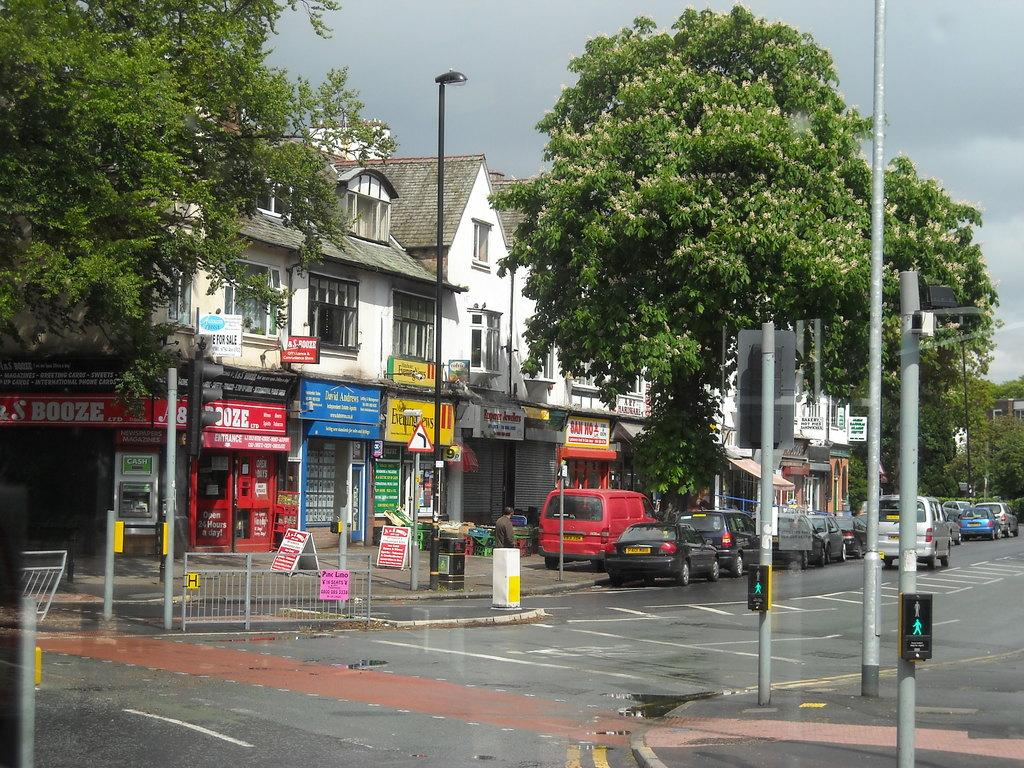Provide a one-sentence caption for the provided image. A street with a number of local business, including one that is called Evening News. 